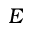<formula> <loc_0><loc_0><loc_500><loc_500>E</formula> 